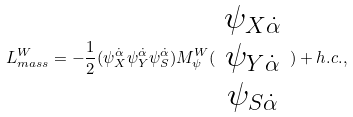Convert formula to latex. <formula><loc_0><loc_0><loc_500><loc_500>L _ { m a s s } ^ { W } = - \frac { 1 } { 2 } ( \psi _ { X } ^ { \dot { \alpha } } \psi _ { Y } ^ { \dot { \alpha } } \psi _ { S } ^ { \dot { \alpha } } ) M _ { \psi } ^ { W } ( \begin{array} { c } \psi _ { X \dot { \alpha } } \\ \psi _ { Y \dot { \alpha } } \\ \psi _ { S \dot { \alpha } } \end{array} ) + h . c . ,</formula> 